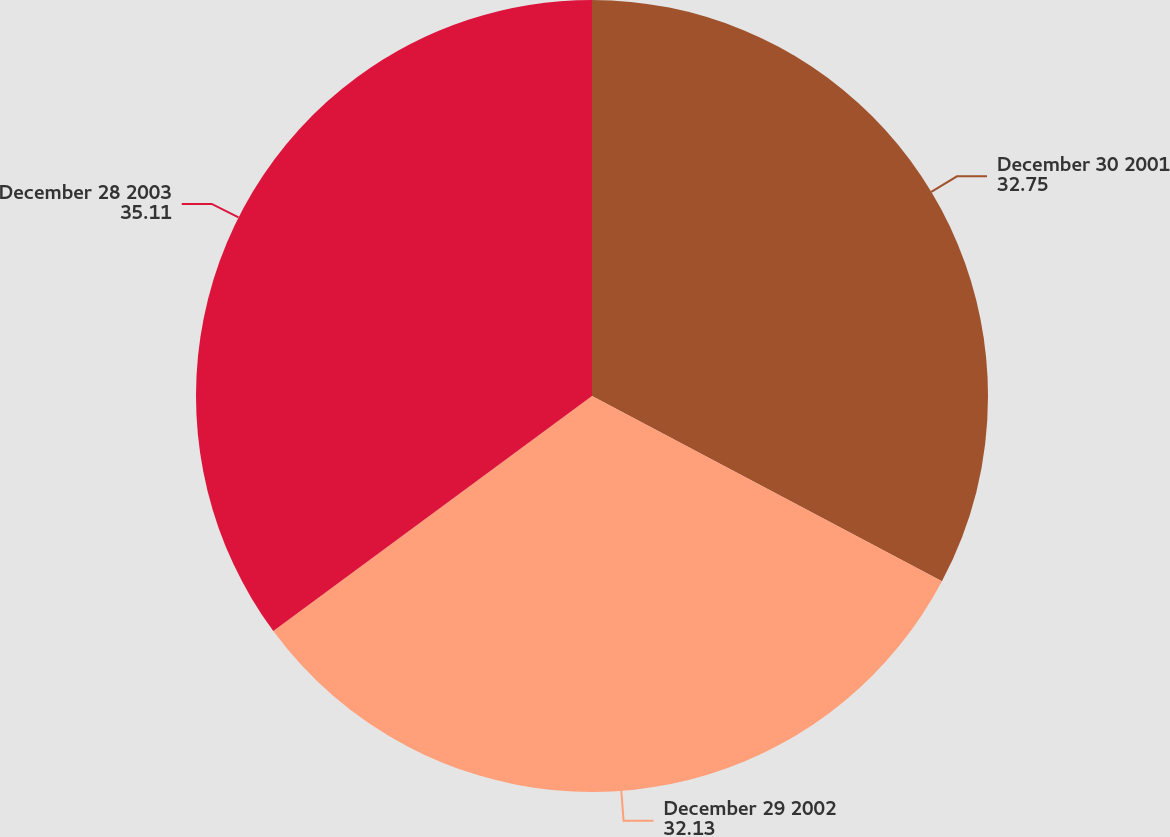Convert chart. <chart><loc_0><loc_0><loc_500><loc_500><pie_chart><fcel>December 30 2001<fcel>December 29 2002<fcel>December 28 2003<nl><fcel>32.75%<fcel>32.13%<fcel>35.11%<nl></chart> 